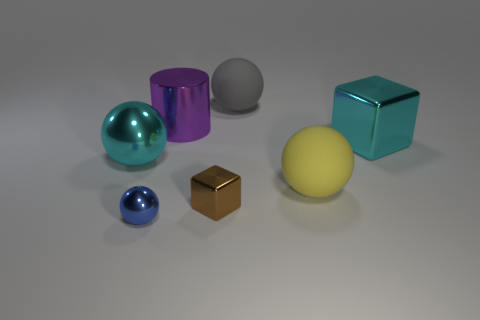There is a matte object that is the same size as the yellow matte sphere; what shape is it?
Your response must be concise. Sphere. What number of metallic objects are small blue things or cyan blocks?
Give a very brief answer. 2. Are the cyan object on the left side of the big cyan block and the block that is behind the cyan metal sphere made of the same material?
Ensure brevity in your answer.  Yes. What color is the tiny object that is the same material as the blue ball?
Offer a very short reply. Brown. Is the number of cyan balls on the left side of the gray object greater than the number of cylinders that are in front of the small shiny ball?
Your answer should be compact. Yes. Are there any small things?
Your answer should be compact. Yes. What material is the block that is the same color as the large shiny ball?
Your response must be concise. Metal. What number of objects are green cylinders or purple metal things?
Ensure brevity in your answer.  1. Are there any tiny shiny cubes that have the same color as the large cube?
Your response must be concise. No. What number of metal cubes are in front of the cyan thing to the left of the big yellow rubber ball?
Provide a succinct answer. 1. 